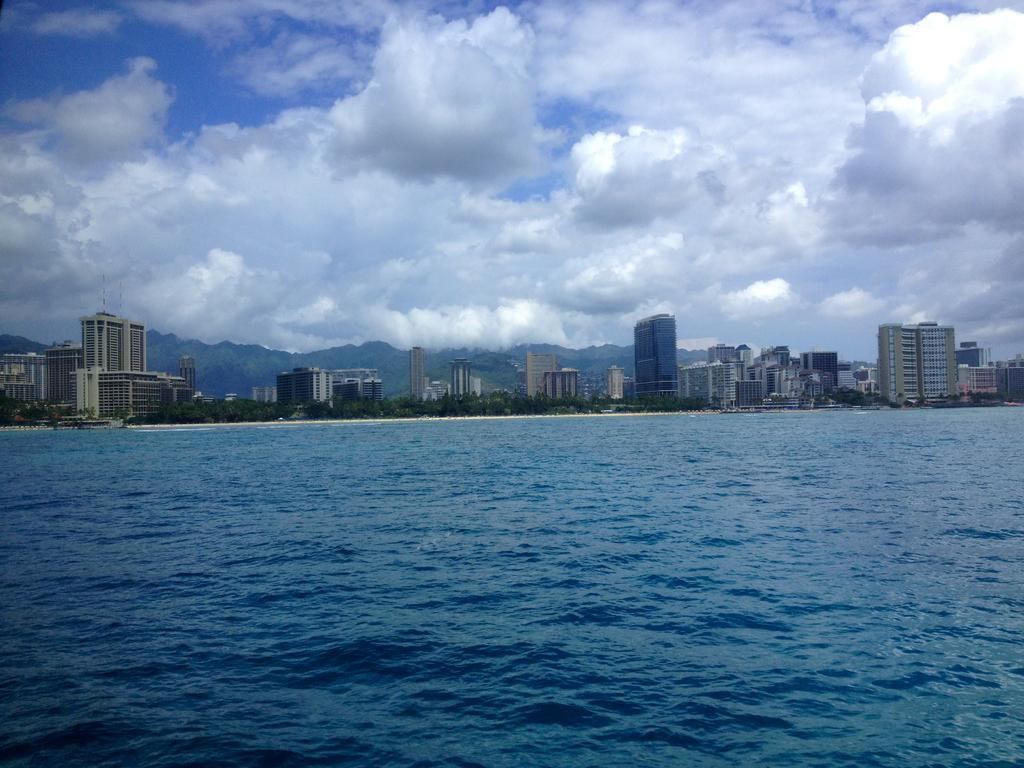What is visible in the image? Water is visible in the image. What can be seen in the background of the image? There are buildings, trees, and the sky visible in the background of the image. How does the sky appear in the image? The sky appears to be cloudy in the image. Where is the daughter playing in the image? There is no daughter present in the image. Can you see any airplanes taking off or landing at the airport in the image? There is no airport or airplanes visible in the image. 